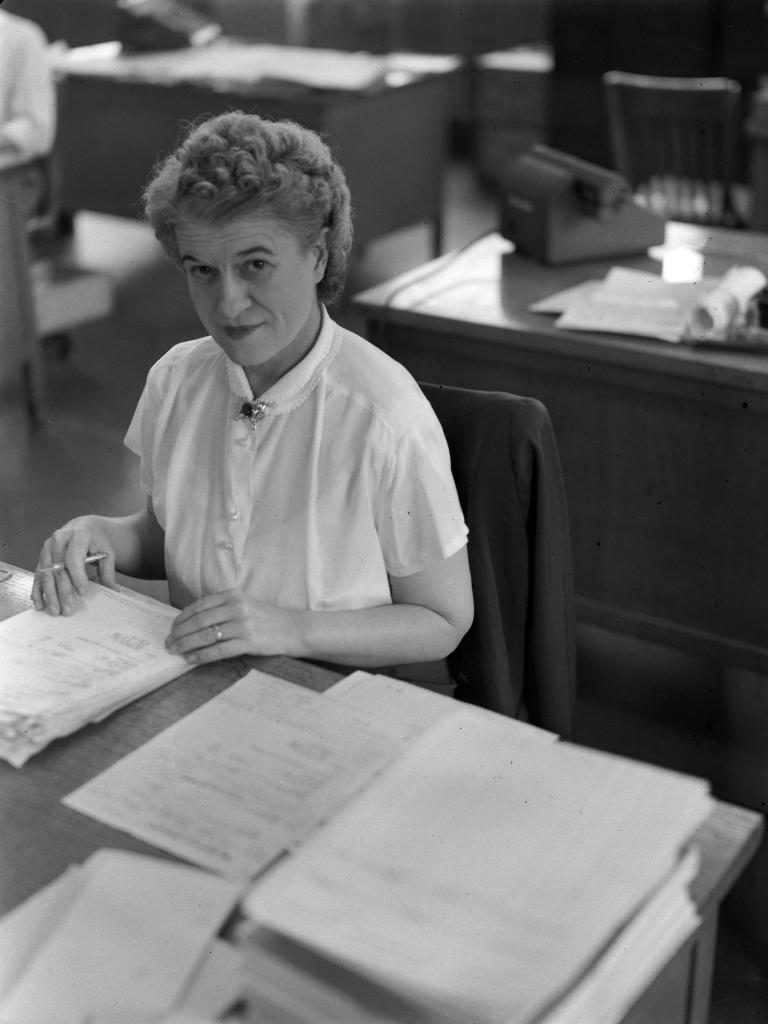Describe this image in one or two sentences. In the image there is a woman siting in the chair and holding the papers which are on the table. At the background there is another table on which there are papers and telephone. 